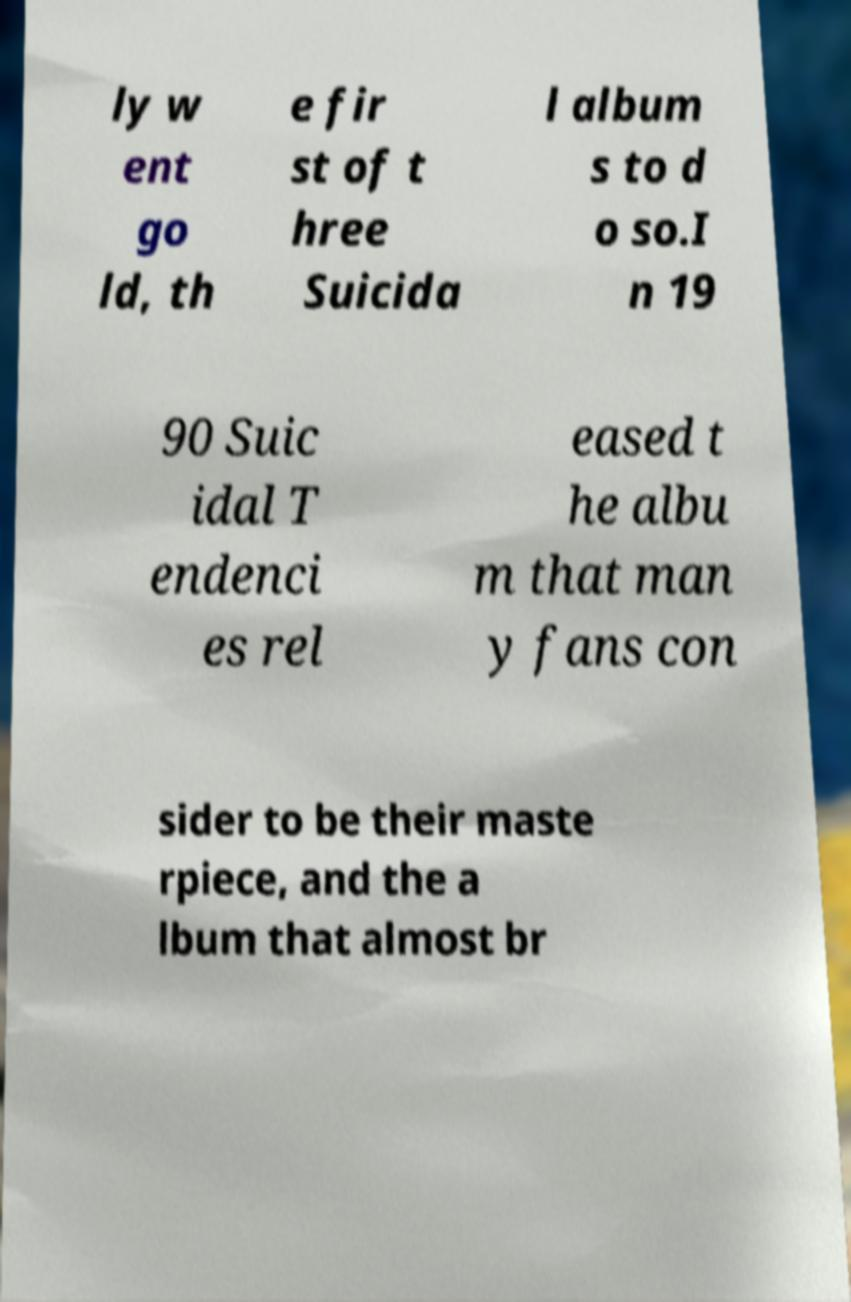For documentation purposes, I need the text within this image transcribed. Could you provide that? ly w ent go ld, th e fir st of t hree Suicida l album s to d o so.I n 19 90 Suic idal T endenci es rel eased t he albu m that man y fans con sider to be their maste rpiece, and the a lbum that almost br 